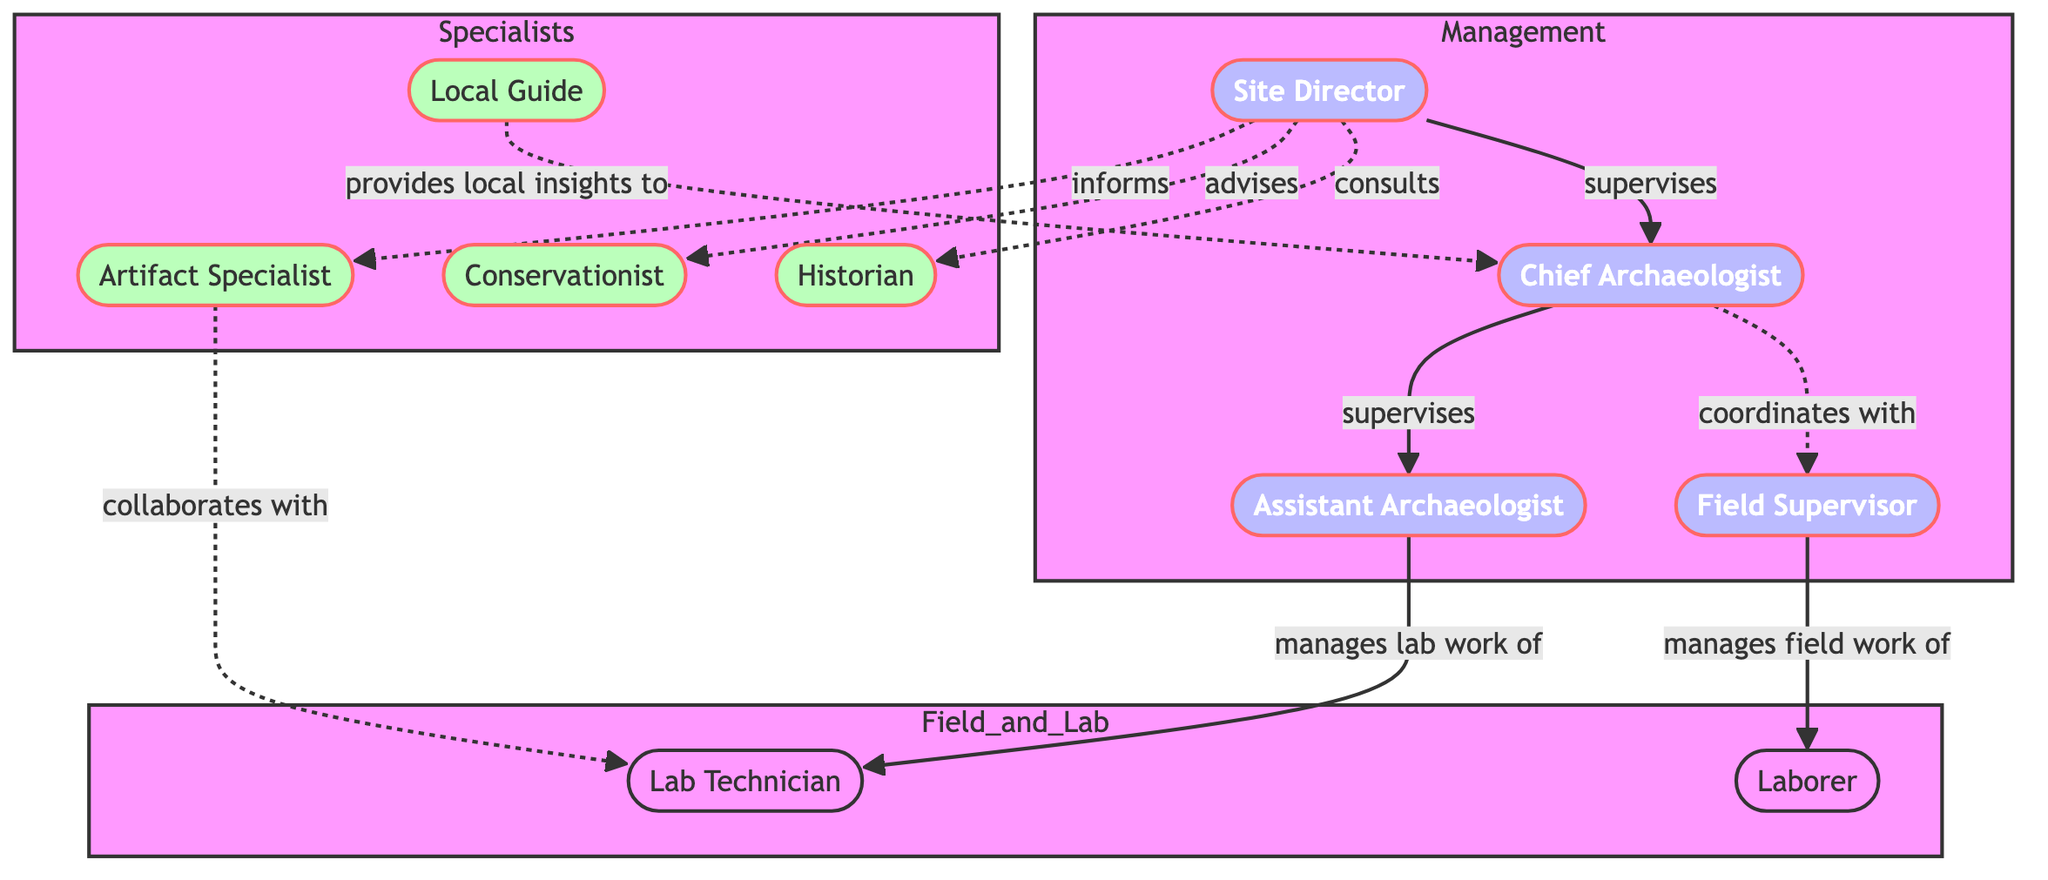How many nodes are in the diagram? The diagram lists the following nodes: Site Director, Chief Archaeologist, Assistant Archaeologist, Field Supervisor, Lab Technician, Local Guide, Artifact Specialist, Conservationist, Historian, Laborer. Counting these gives a total of 10 nodes.
Answer: 10 Who supervises the Chief Archaeologist? The diagram shows a directed edge from Site Director to Chief Archaeologist labeled "supervises." This indicates that the Site Director is the one who supervises the Chief Archaeologist.
Answer: Site Director Which role manages the lab work of the Lab Technician? The Assistant Archaeologist is connected to the Lab Technician with the edge labeled "manages lab work of," indicating that the Assistant Archaeologist is responsible for managing the lab work of the Lab Technician.
Answer: Assistant Archaeologist What is the relationship between the Chief Archaeologist and Field Supervisor? The relationship is indicated by a dashed arrow labeled "coordinates with," signaling that these two roles have a collaborative but less formal relationship compared to direct supervision.
Answer: coordinates with Which role provides local insights to the Chief Archaeologist? The diagram specifies a relationship from Local Guide to Chief Archaeologist with the label "provides local insights to," indicating that the Local Guide is responsible for offering local insights relevant to the Chief Archaeologist.
Answer: Local Guide What is the total number of supervisory relationships in the diagram? By analyzing the edges labeled "supervises," including Site Director to Chief Archaeologist and Chief Archaeologist to Assistant Archaeologist, we find there are four supervisory relationships. They are as follows: 1) Site Director to Chief Archaeologist, 2) Chief Archaeologist to Assistant Archaeologist, 3) Field Supervisor to Laborer (indirect supervision), and 4) Site Director indirectly to other specialist roles. This totals four instructive connections.
Answer: 4 Who does the Chief Archaeologist coordinate with? The edge labeled "coordinates with" specifically links the Chief Archaeologist to the Field Supervisor, indicating a cooperative relationship focused on field operations.
Answer: Field Supervisor How many roles are categorized as Specialists in the diagram? The diagram illustrates a group labeled "Specialists," which includes Artifact Specialist, Conservationist, Historian, and Local Guide. Counting these roles gives a total of four categorized as Specialists.
Answer: 4 What is the role of the Site Director towards the Conservationist? The line between the Site Director and Conservationist is labeled "advises," indicating that the Site Director plays an advisory role concerning the Conservationist’s work.
Answer: advises 